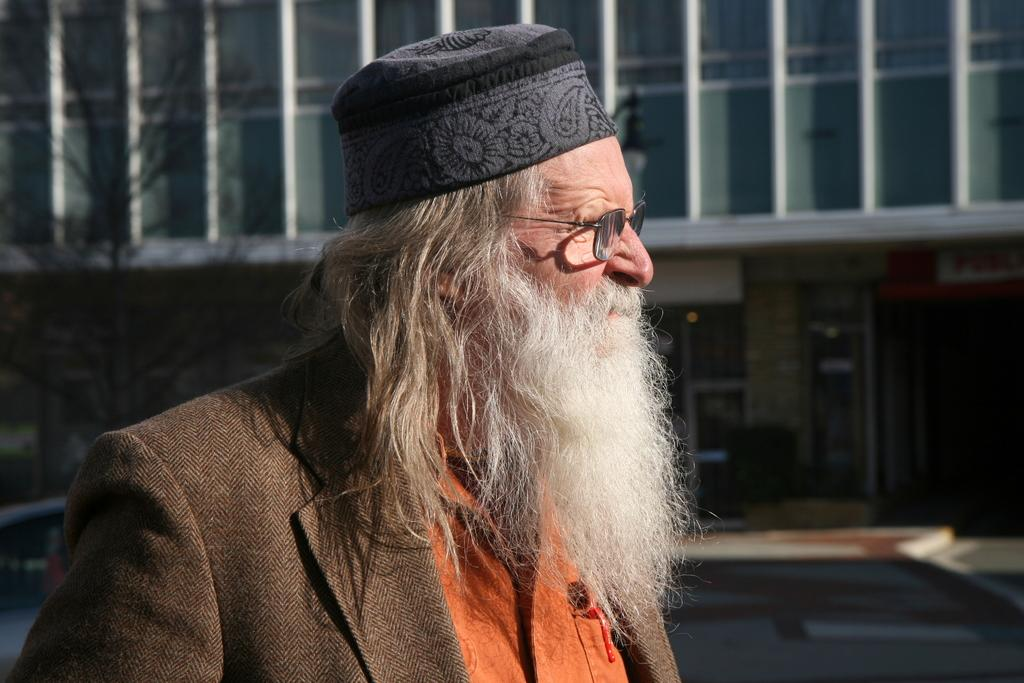Who is present in the image? There is a man in the image. What is the man wearing? The man is wearing spectacles. What can be seen in the background of the image? There is a building and a tree in the background of the image. What type of quince is being used as a representative in the image? There is no quince present in the image, and therefore no such representative can be observed. 